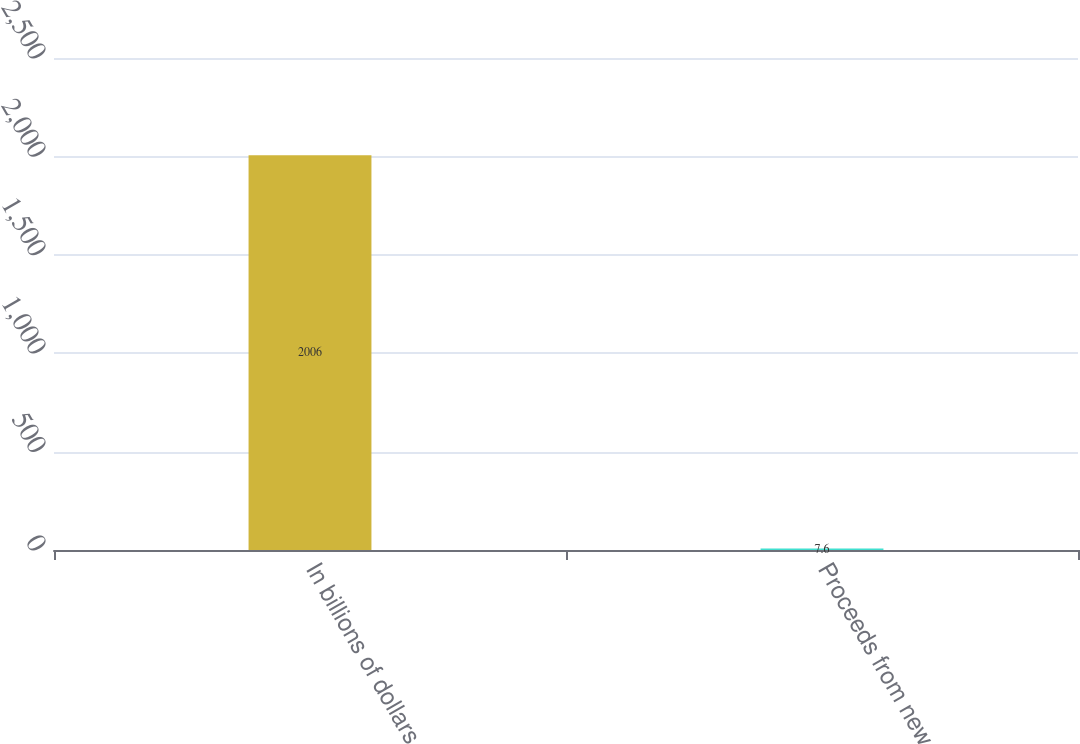<chart> <loc_0><loc_0><loc_500><loc_500><bar_chart><fcel>In billions of dollars<fcel>Proceeds from new<nl><fcel>2006<fcel>7.6<nl></chart> 